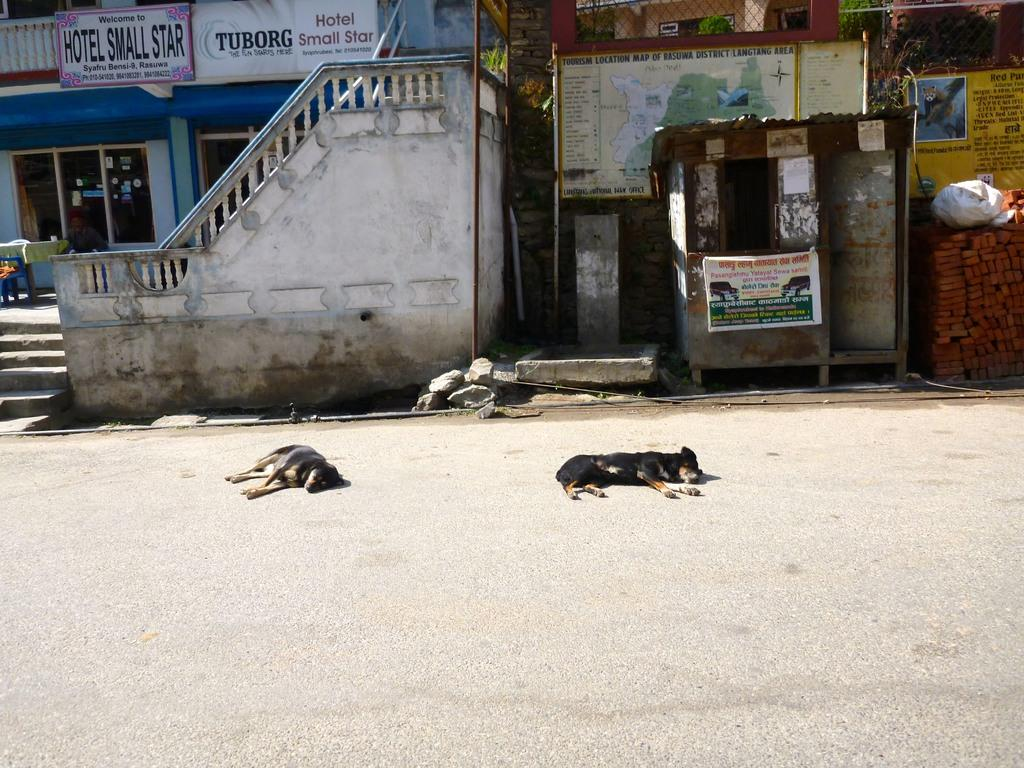What animals can be seen on the road in the image? There are dogs laying on the road in the image. What type of structures are visible in the image? There are houses visible in the image. What type of advertisements are present in the image? There are hoardings in the image. What type of building material is present in the image? Bricks are present in the image. What type of barrier is visible in the image? There is a fence in the image. What type of jelly can be seen on the fence in the image? There is no jelly present in the image, and therefore no such substance can be observed on the fence. 